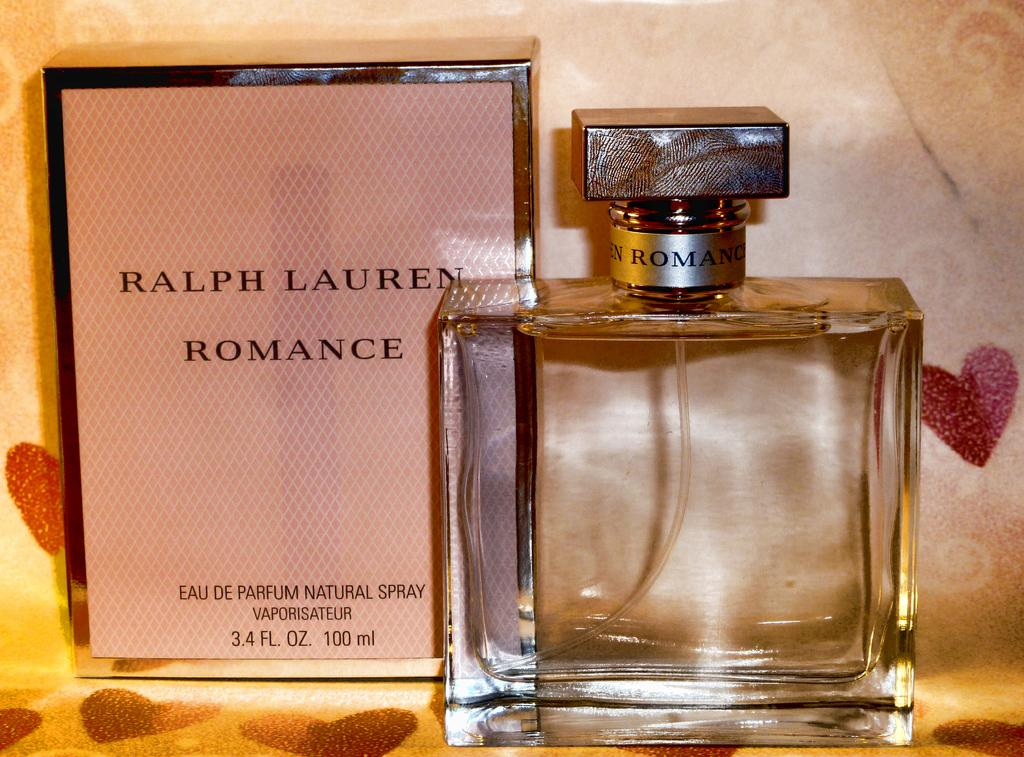<image>
Relay a brief, clear account of the picture shown. A square bottle of Ralph Lauren Romance perfume next to its box. 